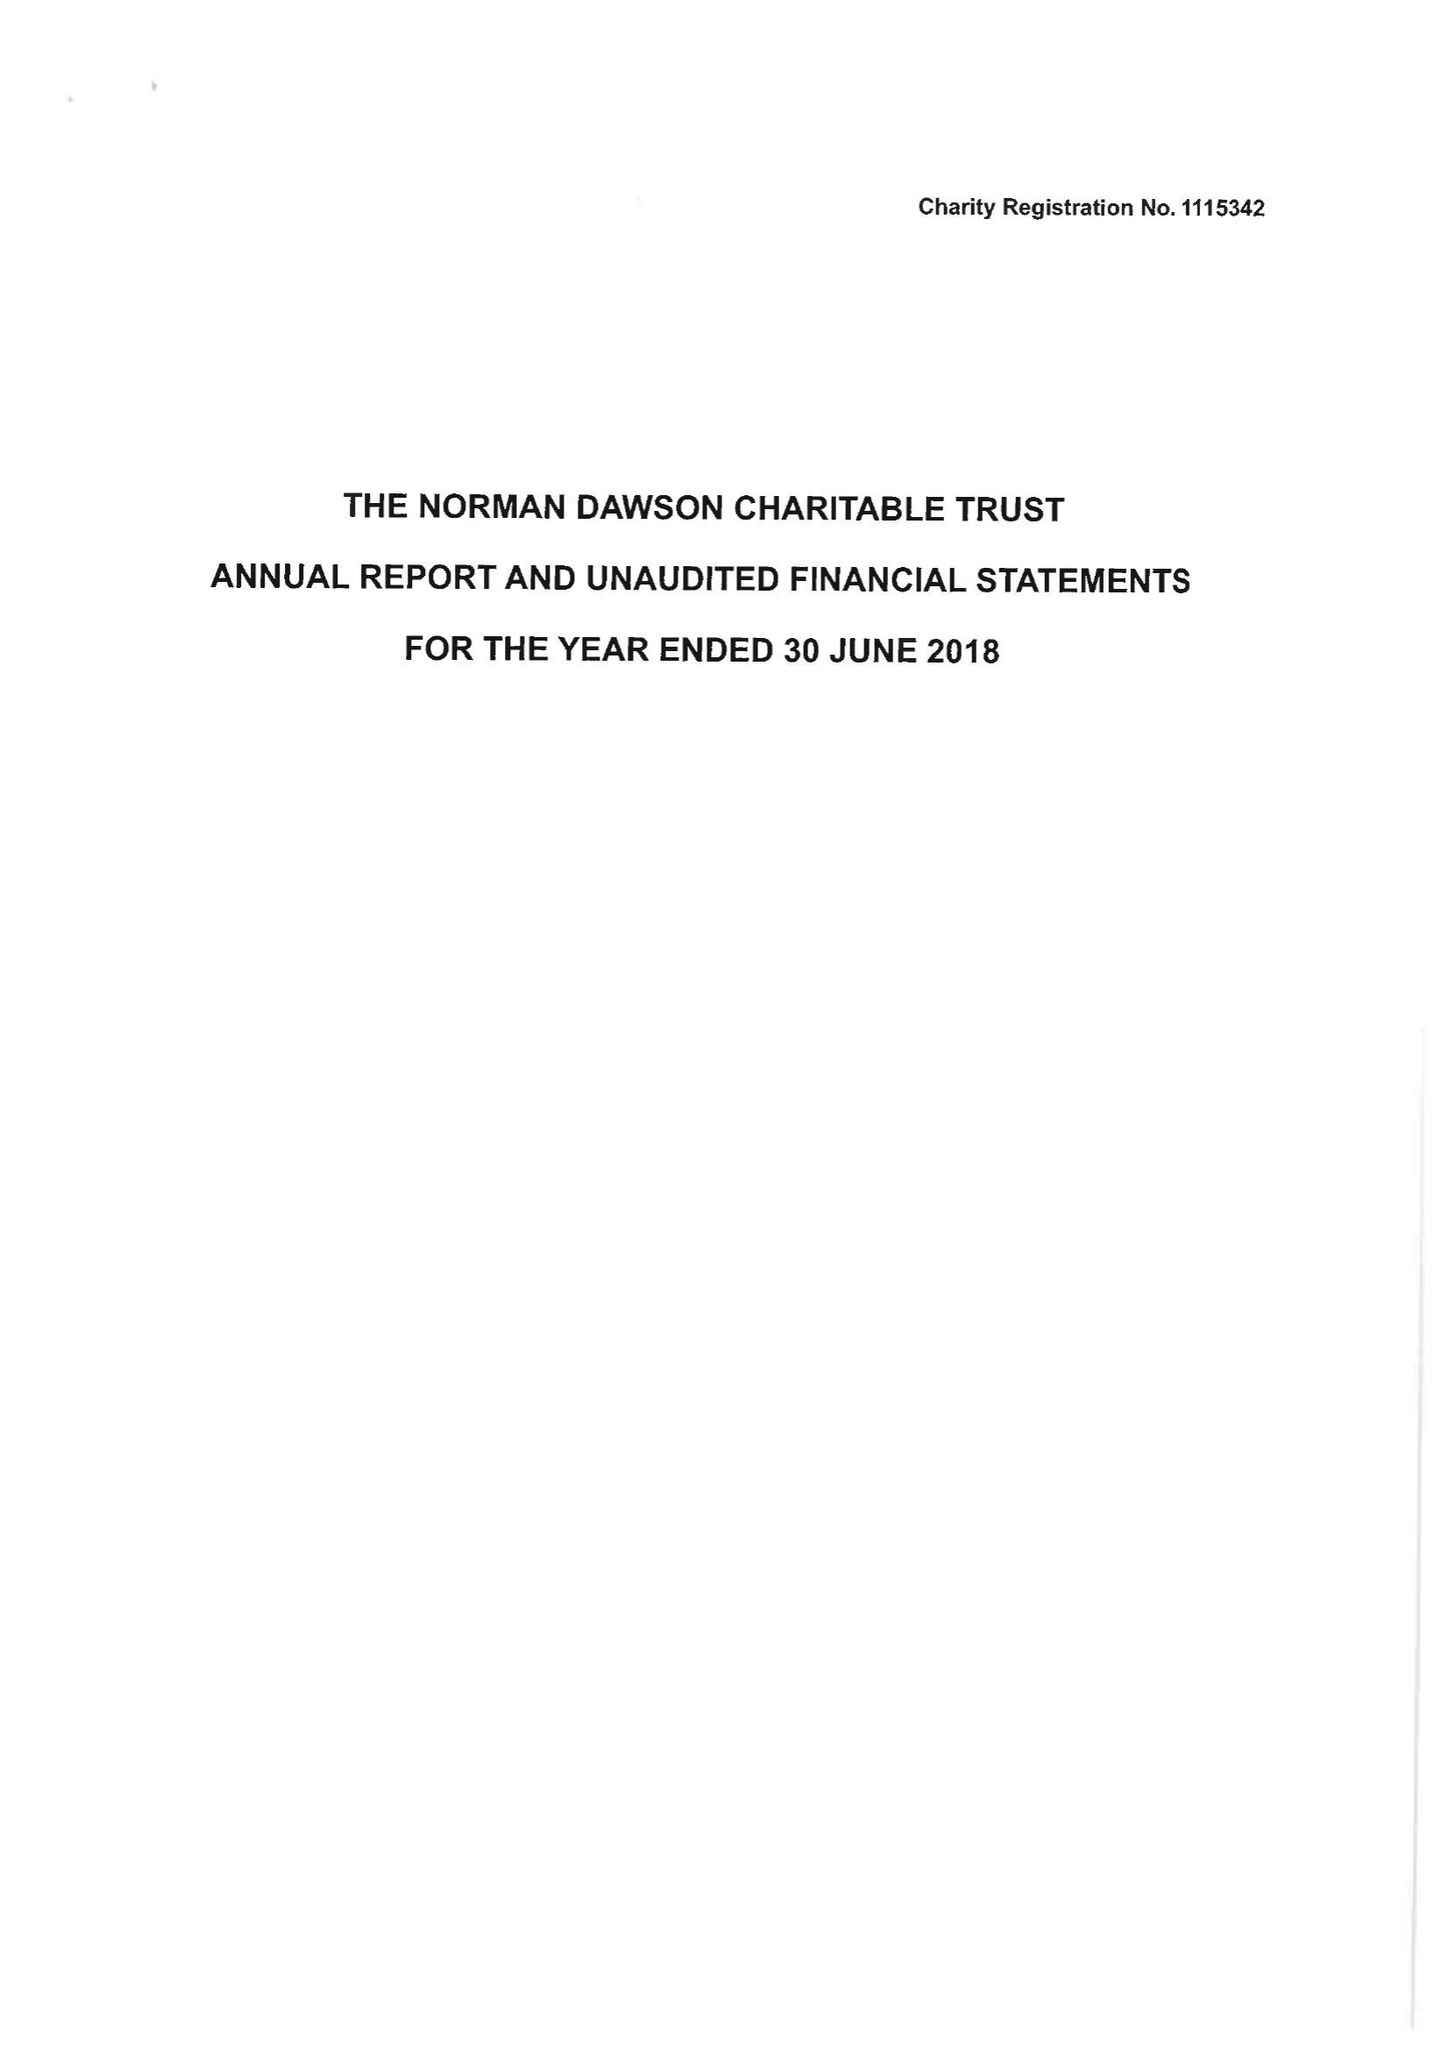What is the value for the address__post_town?
Answer the question using a single word or phrase. KIDDERMINSTER 